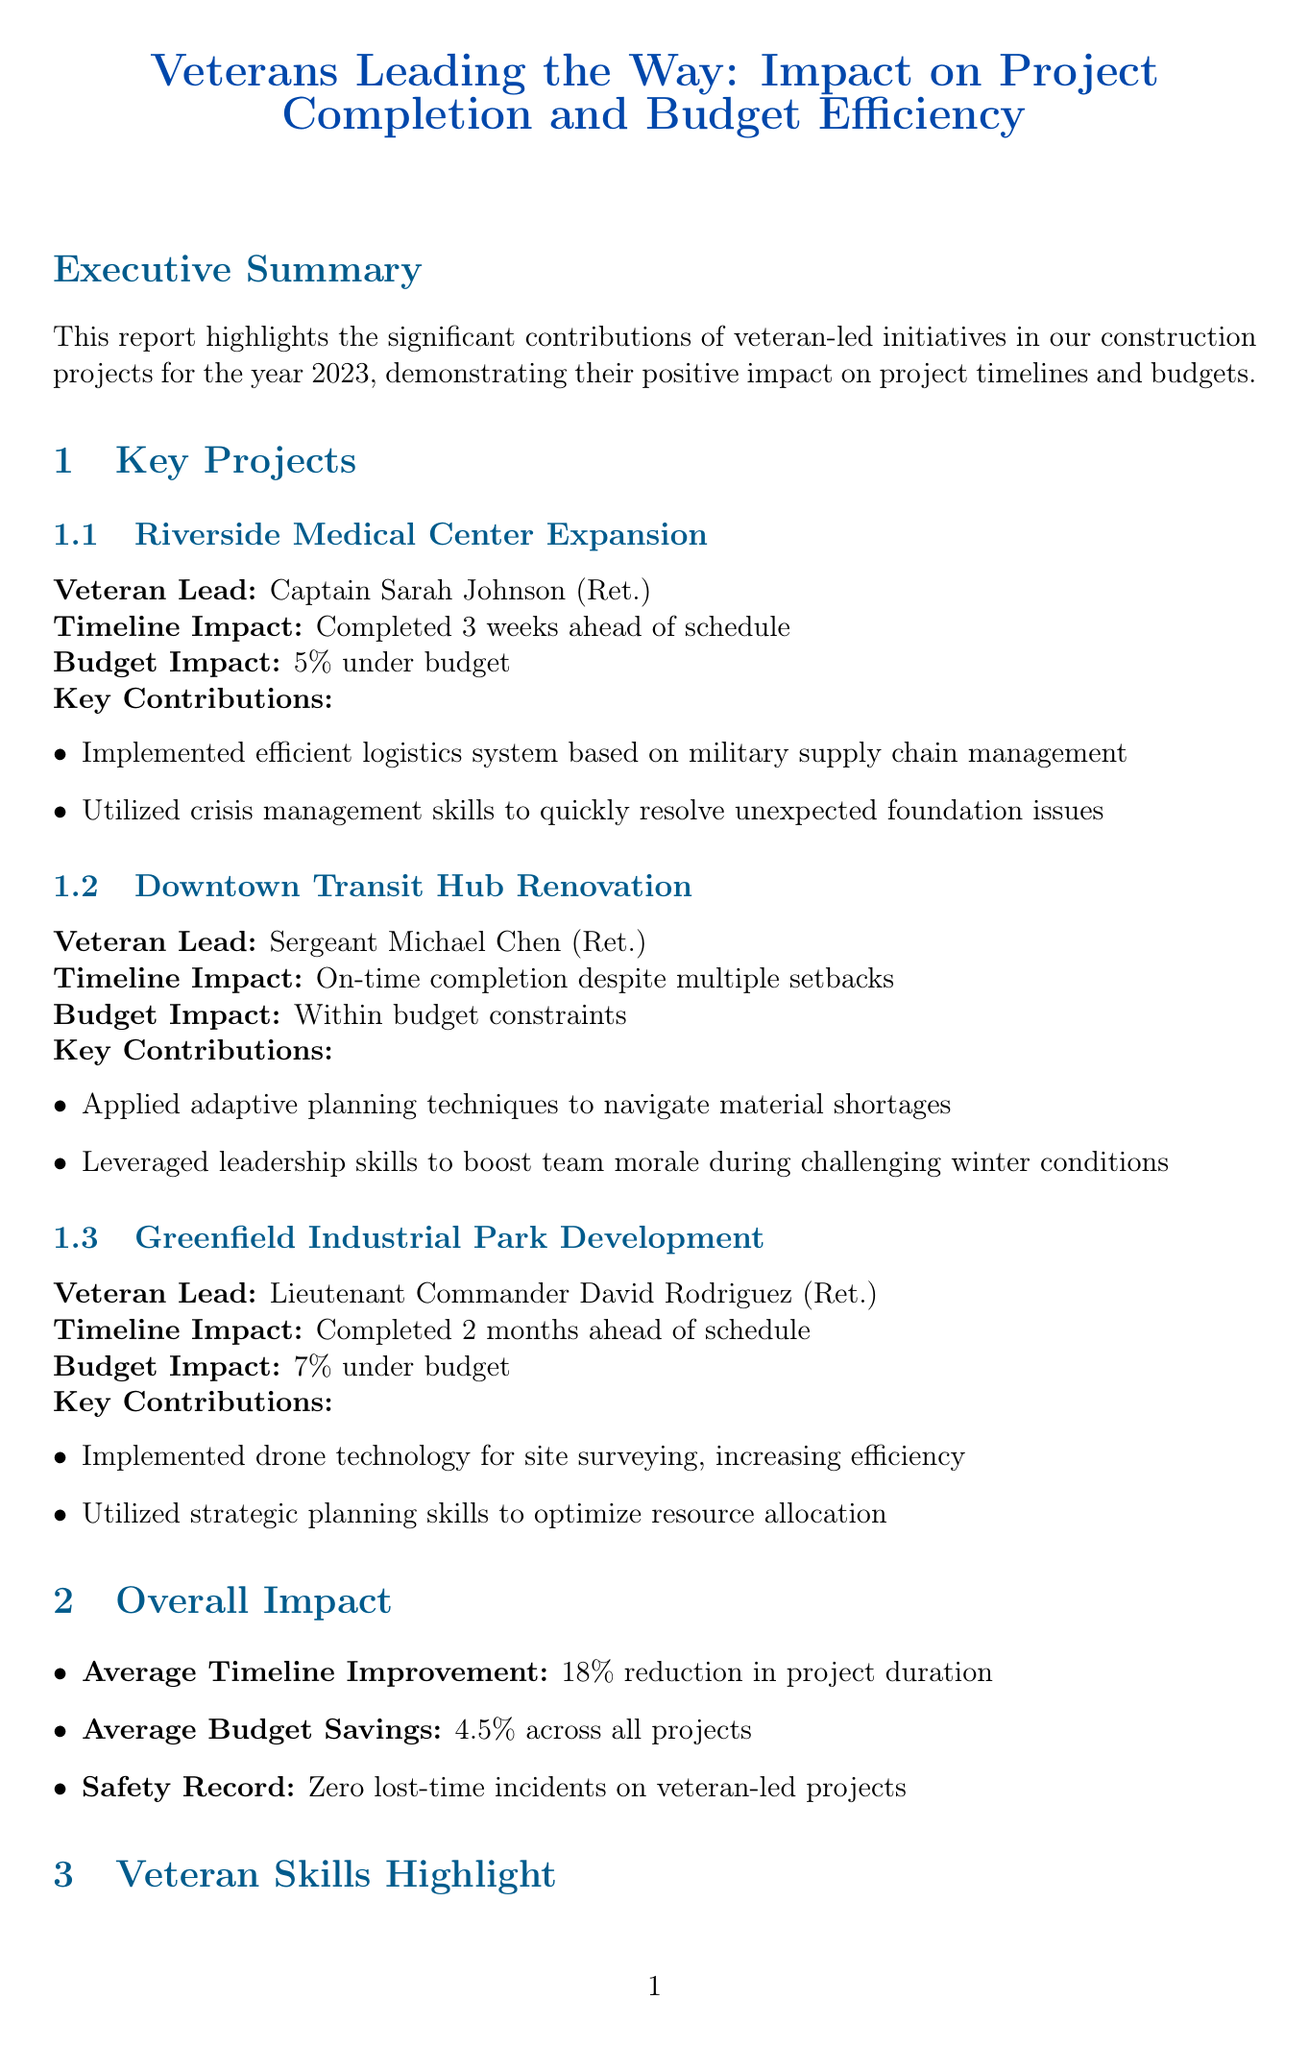What is the title of the report? The title of the report is included at the beginning of the document.
Answer: Veterans Leading the Way: Impact on Project Completion and Budget Efficiency Who led the Riverside Medical Center Expansion project? The document specifies the veteran who was in charge of this project.
Answer: Captain Sarah Johnson (Ret.) What percentage under budget was the Greenfield Industrial Park Development completed? The report states specific budget impacts for each project, including this one.
Answer: 7% under budget How many weeks ahead was the Riverside Medical Center Expansion completed? The timeline impact for each project is clearly listed in the report.
Answer: 3 weeks What skills are highlighted as veteran strengths? The report lists specific skills that veterans bring to the construction industry.
Answer: Leadership and team management, Adaptability and problem-solving, Logistics and resource management, Safety-first mindset, Discipline and attention to detail What was the average budget savings across all projects? The overall impact section provides an average budget number derived from all projects.
Answer: 4.5% Who provided a testimonial about Captain Johnson? The testimonials section names individuals who provided quotes regarding veteran contributions.
Answer: Frank Thompson What is one of the future initiatives mentioned in the report? The future initiatives section outlines plans for the organization moving forward.
Answer: Expand veteran recruitment program 